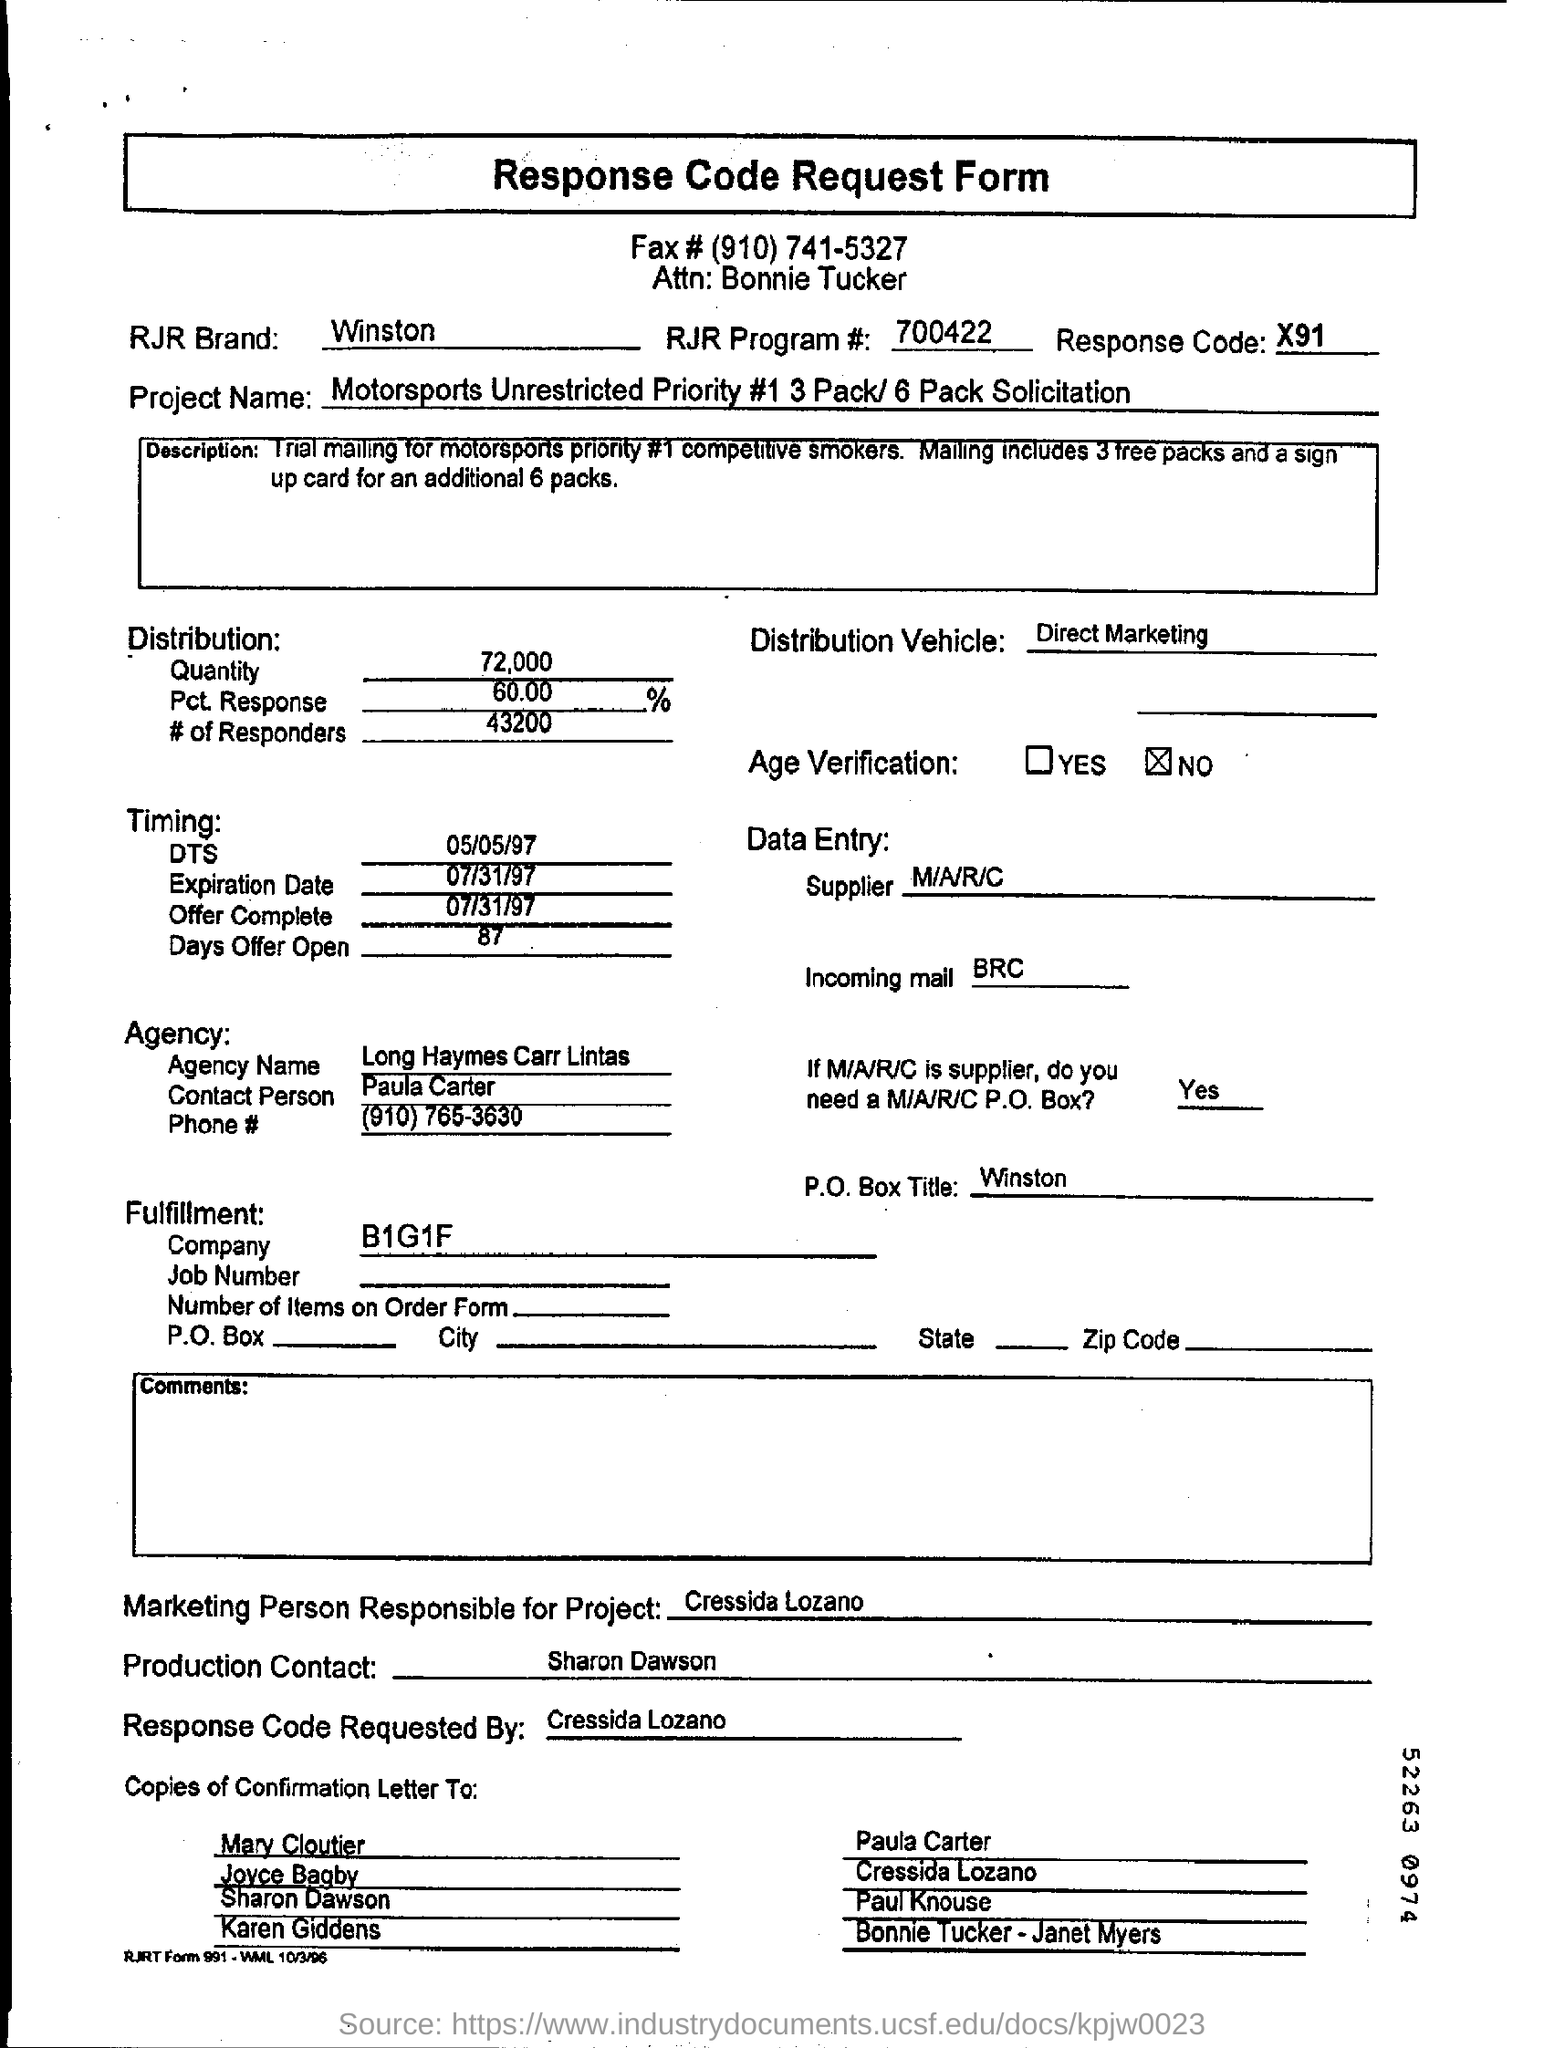What project is related to this form? The form is related to the 'Motorsports Unrestricted Priority #1 3 Pack/6 Pack Solicitation' project. This project seems to be a marketing initiative focused on promoting the Winston brand within the motorsports audience. 